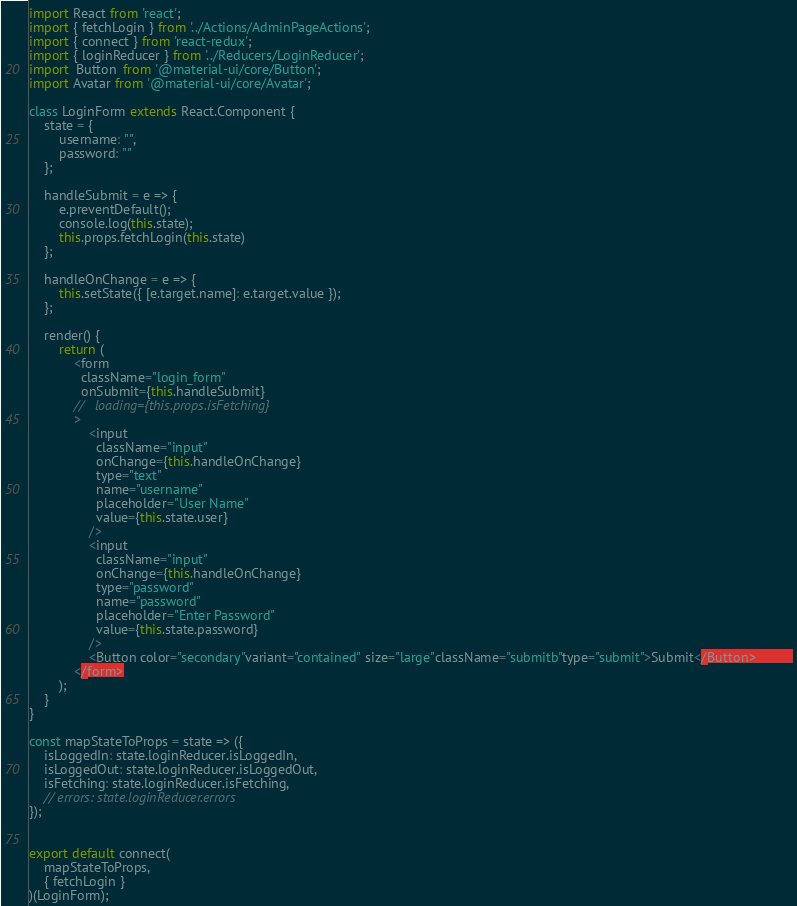<code> <loc_0><loc_0><loc_500><loc_500><_JavaScript_>import React from 'react';
import { fetchLogin } from '../Actions/AdminPageActions';
import { connect } from 'react-redux';
import { loginReducer } from '../Reducers/LoginReducer';
import  Button  from '@material-ui/core/Button';
import Avatar from '@material-ui/core/Avatar';

class LoginForm extends React.Component {
    state = {
        username: "",
        password: ""
    };

    handleSubmit = e => {
        e.preventDefault();
        console.log(this.state);
        this.props.fetchLogin(this.state)
    };

    handleOnChange = e => {
        this.setState({ [e.target.name]: e.target.value });
    };

    render() {
        return (
            <form 
              className="login_form"
              onSubmit={this.handleSubmit}
            //   loading={this.props.isFetching}
            >
                <input
                  className="input"
                  onChange={this.handleOnChange}
                  type="text"
                  name="username"
                  placeholder="User Name"
                  value={this.state.user}
                />
                <input
                  className="input"
                  onChange={this.handleOnChange}
                  type="password"
                  name="password"
                  placeholder="Enter Password"
                  value={this.state.password}
                />
                <Button color="secondary"variant="contained" size="large"className="submitb"type="submit">Submit</Button>         
            </form>
        );
    }
}

const mapStateToProps = state => ({
    isLoggedIn: state.loginReducer.isLoggedIn,
    isLoggedOut: state.loginReducer.isLoggedOut,
    isFetching: state.loginReducer.isFetching,
    // errors: state.loginReducer.errors
});


export default connect(
    mapStateToProps,
    { fetchLogin }
)(LoginForm);</code> 